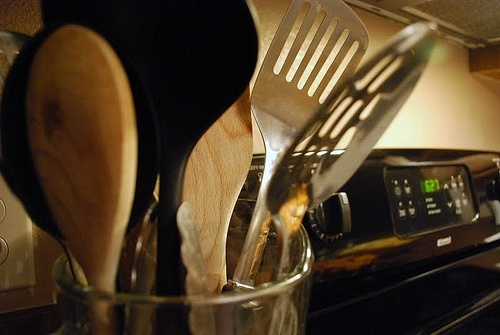Describe the objects in this image and their specific colors. I can see oven in black, olive, maroon, and gray tones, spoon in black, maroon, and olive tones, spoon in black, gray, and tan tones, spoon in black, olive, tan, and maroon tones, and fork in black, maroon, olive, and tan tones in this image. 